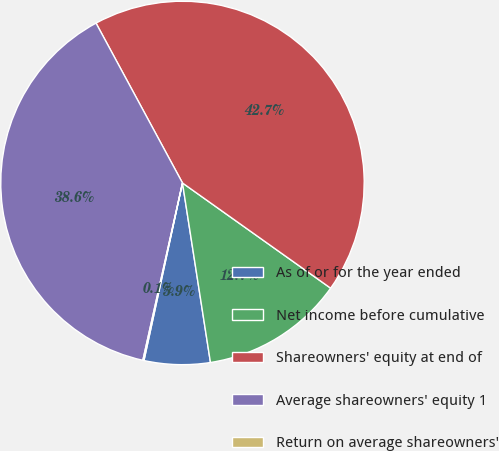Convert chart to OTSL. <chart><loc_0><loc_0><loc_500><loc_500><pie_chart><fcel>As of or for the year ended<fcel>Net income before cumulative<fcel>Shareowners' equity at end of<fcel>Average shareowners' equity 1<fcel>Return on average shareowners'<nl><fcel>5.86%<fcel>12.71%<fcel>42.72%<fcel>38.61%<fcel>0.1%<nl></chart> 